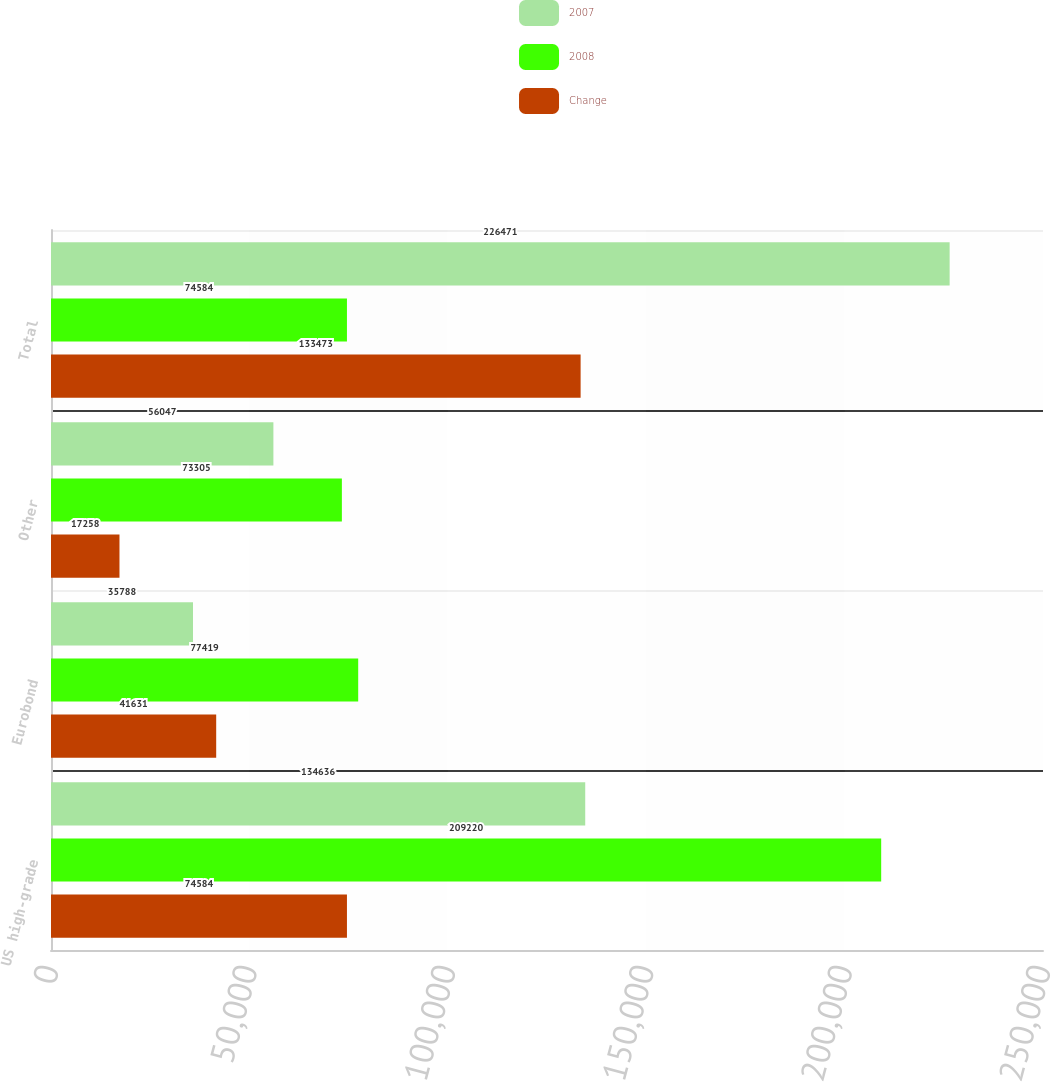Convert chart. <chart><loc_0><loc_0><loc_500><loc_500><stacked_bar_chart><ecel><fcel>US high-grade<fcel>Eurobond<fcel>Other<fcel>Total<nl><fcel>2007<fcel>134636<fcel>35788<fcel>56047<fcel>226471<nl><fcel>2008<fcel>209220<fcel>77419<fcel>73305<fcel>74584<nl><fcel>Change<fcel>74584<fcel>41631<fcel>17258<fcel>133473<nl></chart> 